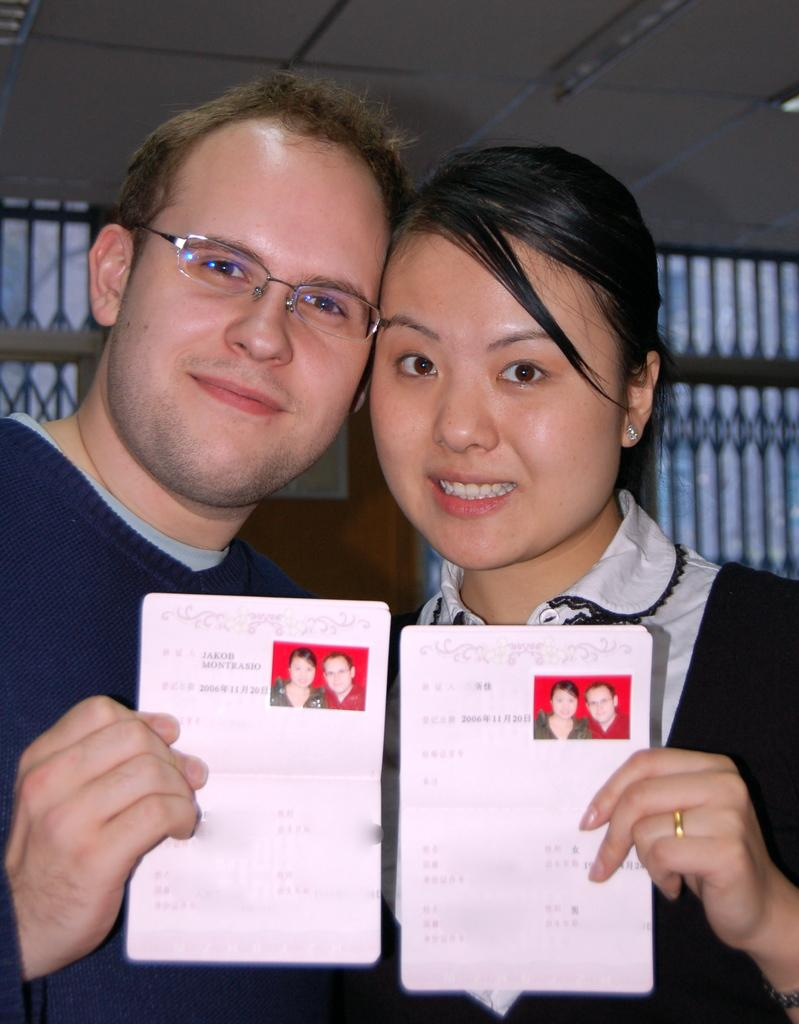How many people are in the image? There are two persons standing in the middle of the image. What are the persons doing in the image? The persons are smiling and holding papers. What is behind the persons in the image? There is a wall behind the persons. What can be seen at the top of the image? The ceiling is visible at the top of the image. How many snakes are coiled around the persons in the image? There are no snakes present in the image. What shape is formed by the persons standing together in the image? The image does not depict a specific shape formed by the persons standing together. 